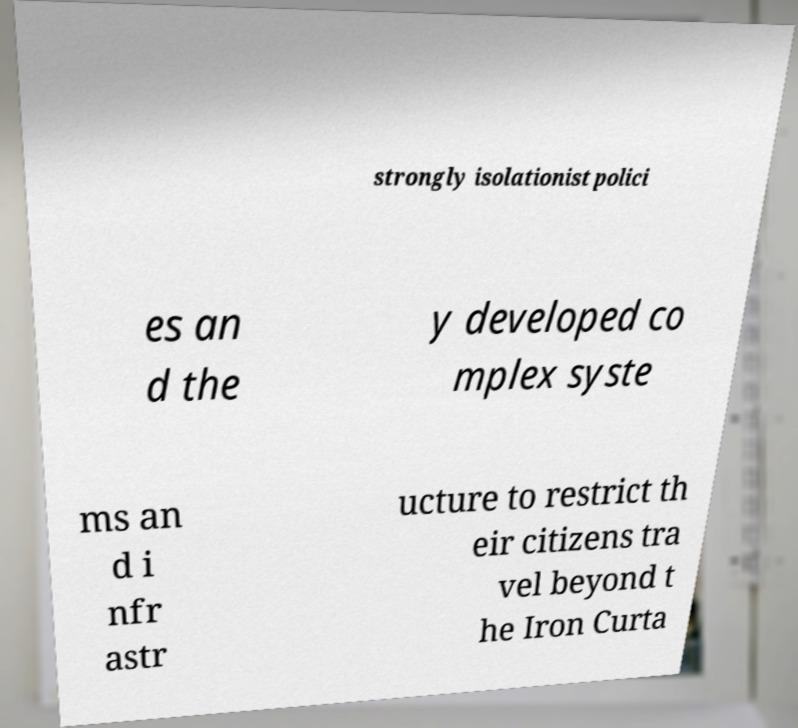Could you extract and type out the text from this image? strongly isolationist polici es an d the y developed co mplex syste ms an d i nfr astr ucture to restrict th eir citizens tra vel beyond t he Iron Curta 